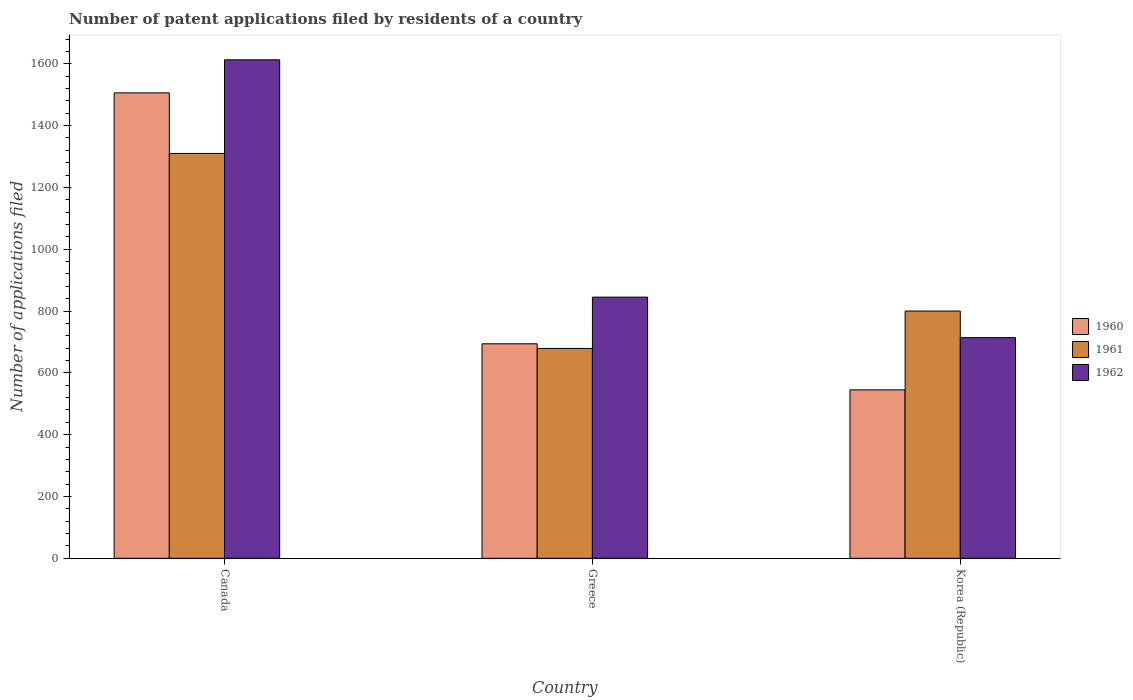How many different coloured bars are there?
Offer a terse response. 3. How many groups of bars are there?
Offer a very short reply. 3. How many bars are there on the 3rd tick from the right?
Your answer should be compact. 3. In how many cases, is the number of bars for a given country not equal to the number of legend labels?
Offer a very short reply. 0. What is the number of applications filed in 1960 in Greece?
Give a very brief answer. 694. Across all countries, what is the maximum number of applications filed in 1960?
Your answer should be compact. 1506. Across all countries, what is the minimum number of applications filed in 1962?
Keep it short and to the point. 714. In which country was the number of applications filed in 1961 minimum?
Your answer should be very brief. Greece. What is the total number of applications filed in 1961 in the graph?
Give a very brief answer. 2789. What is the difference between the number of applications filed in 1961 in Greece and that in Korea (Republic)?
Keep it short and to the point. -121. What is the difference between the number of applications filed in 1961 in Greece and the number of applications filed in 1960 in Korea (Republic)?
Offer a terse response. 134. What is the average number of applications filed in 1961 per country?
Ensure brevity in your answer.  929.67. What is the difference between the number of applications filed of/in 1960 and number of applications filed of/in 1961 in Canada?
Your answer should be very brief. 196. In how many countries, is the number of applications filed in 1961 greater than 520?
Your answer should be compact. 3. What is the ratio of the number of applications filed in 1960 in Greece to that in Korea (Republic)?
Your answer should be very brief. 1.27. What is the difference between the highest and the second highest number of applications filed in 1961?
Provide a short and direct response. -510. What is the difference between the highest and the lowest number of applications filed in 1961?
Your answer should be compact. 631. What does the 2nd bar from the left in Canada represents?
Provide a short and direct response. 1961. How many countries are there in the graph?
Keep it short and to the point. 3. Are the values on the major ticks of Y-axis written in scientific E-notation?
Keep it short and to the point. No. Does the graph contain any zero values?
Ensure brevity in your answer.  No. Where does the legend appear in the graph?
Make the answer very short. Center right. What is the title of the graph?
Make the answer very short. Number of patent applications filed by residents of a country. What is the label or title of the Y-axis?
Provide a succinct answer. Number of applications filed. What is the Number of applications filed of 1960 in Canada?
Give a very brief answer. 1506. What is the Number of applications filed in 1961 in Canada?
Your response must be concise. 1310. What is the Number of applications filed of 1962 in Canada?
Give a very brief answer. 1613. What is the Number of applications filed in 1960 in Greece?
Ensure brevity in your answer.  694. What is the Number of applications filed of 1961 in Greece?
Offer a terse response. 679. What is the Number of applications filed of 1962 in Greece?
Your answer should be compact. 845. What is the Number of applications filed of 1960 in Korea (Republic)?
Provide a short and direct response. 545. What is the Number of applications filed of 1961 in Korea (Republic)?
Your answer should be compact. 800. What is the Number of applications filed in 1962 in Korea (Republic)?
Your answer should be compact. 714. Across all countries, what is the maximum Number of applications filed of 1960?
Make the answer very short. 1506. Across all countries, what is the maximum Number of applications filed of 1961?
Give a very brief answer. 1310. Across all countries, what is the maximum Number of applications filed in 1962?
Your answer should be very brief. 1613. Across all countries, what is the minimum Number of applications filed in 1960?
Your answer should be compact. 545. Across all countries, what is the minimum Number of applications filed in 1961?
Your answer should be compact. 679. Across all countries, what is the minimum Number of applications filed in 1962?
Offer a very short reply. 714. What is the total Number of applications filed in 1960 in the graph?
Provide a succinct answer. 2745. What is the total Number of applications filed in 1961 in the graph?
Your answer should be compact. 2789. What is the total Number of applications filed of 1962 in the graph?
Give a very brief answer. 3172. What is the difference between the Number of applications filed in 1960 in Canada and that in Greece?
Keep it short and to the point. 812. What is the difference between the Number of applications filed in 1961 in Canada and that in Greece?
Your answer should be very brief. 631. What is the difference between the Number of applications filed of 1962 in Canada and that in Greece?
Your answer should be compact. 768. What is the difference between the Number of applications filed of 1960 in Canada and that in Korea (Republic)?
Your answer should be very brief. 961. What is the difference between the Number of applications filed of 1961 in Canada and that in Korea (Republic)?
Your answer should be very brief. 510. What is the difference between the Number of applications filed of 1962 in Canada and that in Korea (Republic)?
Give a very brief answer. 899. What is the difference between the Number of applications filed of 1960 in Greece and that in Korea (Republic)?
Make the answer very short. 149. What is the difference between the Number of applications filed of 1961 in Greece and that in Korea (Republic)?
Your answer should be very brief. -121. What is the difference between the Number of applications filed in 1962 in Greece and that in Korea (Republic)?
Offer a terse response. 131. What is the difference between the Number of applications filed in 1960 in Canada and the Number of applications filed in 1961 in Greece?
Your response must be concise. 827. What is the difference between the Number of applications filed of 1960 in Canada and the Number of applications filed of 1962 in Greece?
Offer a very short reply. 661. What is the difference between the Number of applications filed in 1961 in Canada and the Number of applications filed in 1962 in Greece?
Your answer should be very brief. 465. What is the difference between the Number of applications filed of 1960 in Canada and the Number of applications filed of 1961 in Korea (Republic)?
Keep it short and to the point. 706. What is the difference between the Number of applications filed in 1960 in Canada and the Number of applications filed in 1962 in Korea (Republic)?
Offer a terse response. 792. What is the difference between the Number of applications filed in 1961 in Canada and the Number of applications filed in 1962 in Korea (Republic)?
Your response must be concise. 596. What is the difference between the Number of applications filed in 1960 in Greece and the Number of applications filed in 1961 in Korea (Republic)?
Provide a short and direct response. -106. What is the difference between the Number of applications filed of 1961 in Greece and the Number of applications filed of 1962 in Korea (Republic)?
Provide a succinct answer. -35. What is the average Number of applications filed of 1960 per country?
Give a very brief answer. 915. What is the average Number of applications filed of 1961 per country?
Your answer should be very brief. 929.67. What is the average Number of applications filed of 1962 per country?
Keep it short and to the point. 1057.33. What is the difference between the Number of applications filed of 1960 and Number of applications filed of 1961 in Canada?
Offer a terse response. 196. What is the difference between the Number of applications filed of 1960 and Number of applications filed of 1962 in Canada?
Provide a succinct answer. -107. What is the difference between the Number of applications filed of 1961 and Number of applications filed of 1962 in Canada?
Make the answer very short. -303. What is the difference between the Number of applications filed in 1960 and Number of applications filed in 1962 in Greece?
Your answer should be very brief. -151. What is the difference between the Number of applications filed in 1961 and Number of applications filed in 1962 in Greece?
Your answer should be very brief. -166. What is the difference between the Number of applications filed of 1960 and Number of applications filed of 1961 in Korea (Republic)?
Keep it short and to the point. -255. What is the difference between the Number of applications filed of 1960 and Number of applications filed of 1962 in Korea (Republic)?
Provide a succinct answer. -169. What is the ratio of the Number of applications filed of 1960 in Canada to that in Greece?
Keep it short and to the point. 2.17. What is the ratio of the Number of applications filed in 1961 in Canada to that in Greece?
Offer a terse response. 1.93. What is the ratio of the Number of applications filed of 1962 in Canada to that in Greece?
Ensure brevity in your answer.  1.91. What is the ratio of the Number of applications filed of 1960 in Canada to that in Korea (Republic)?
Offer a terse response. 2.76. What is the ratio of the Number of applications filed in 1961 in Canada to that in Korea (Republic)?
Keep it short and to the point. 1.64. What is the ratio of the Number of applications filed of 1962 in Canada to that in Korea (Republic)?
Offer a terse response. 2.26. What is the ratio of the Number of applications filed in 1960 in Greece to that in Korea (Republic)?
Offer a very short reply. 1.27. What is the ratio of the Number of applications filed in 1961 in Greece to that in Korea (Republic)?
Provide a short and direct response. 0.85. What is the ratio of the Number of applications filed of 1962 in Greece to that in Korea (Republic)?
Provide a succinct answer. 1.18. What is the difference between the highest and the second highest Number of applications filed in 1960?
Make the answer very short. 812. What is the difference between the highest and the second highest Number of applications filed in 1961?
Your answer should be compact. 510. What is the difference between the highest and the second highest Number of applications filed of 1962?
Your answer should be very brief. 768. What is the difference between the highest and the lowest Number of applications filed in 1960?
Provide a short and direct response. 961. What is the difference between the highest and the lowest Number of applications filed of 1961?
Offer a terse response. 631. What is the difference between the highest and the lowest Number of applications filed of 1962?
Offer a terse response. 899. 